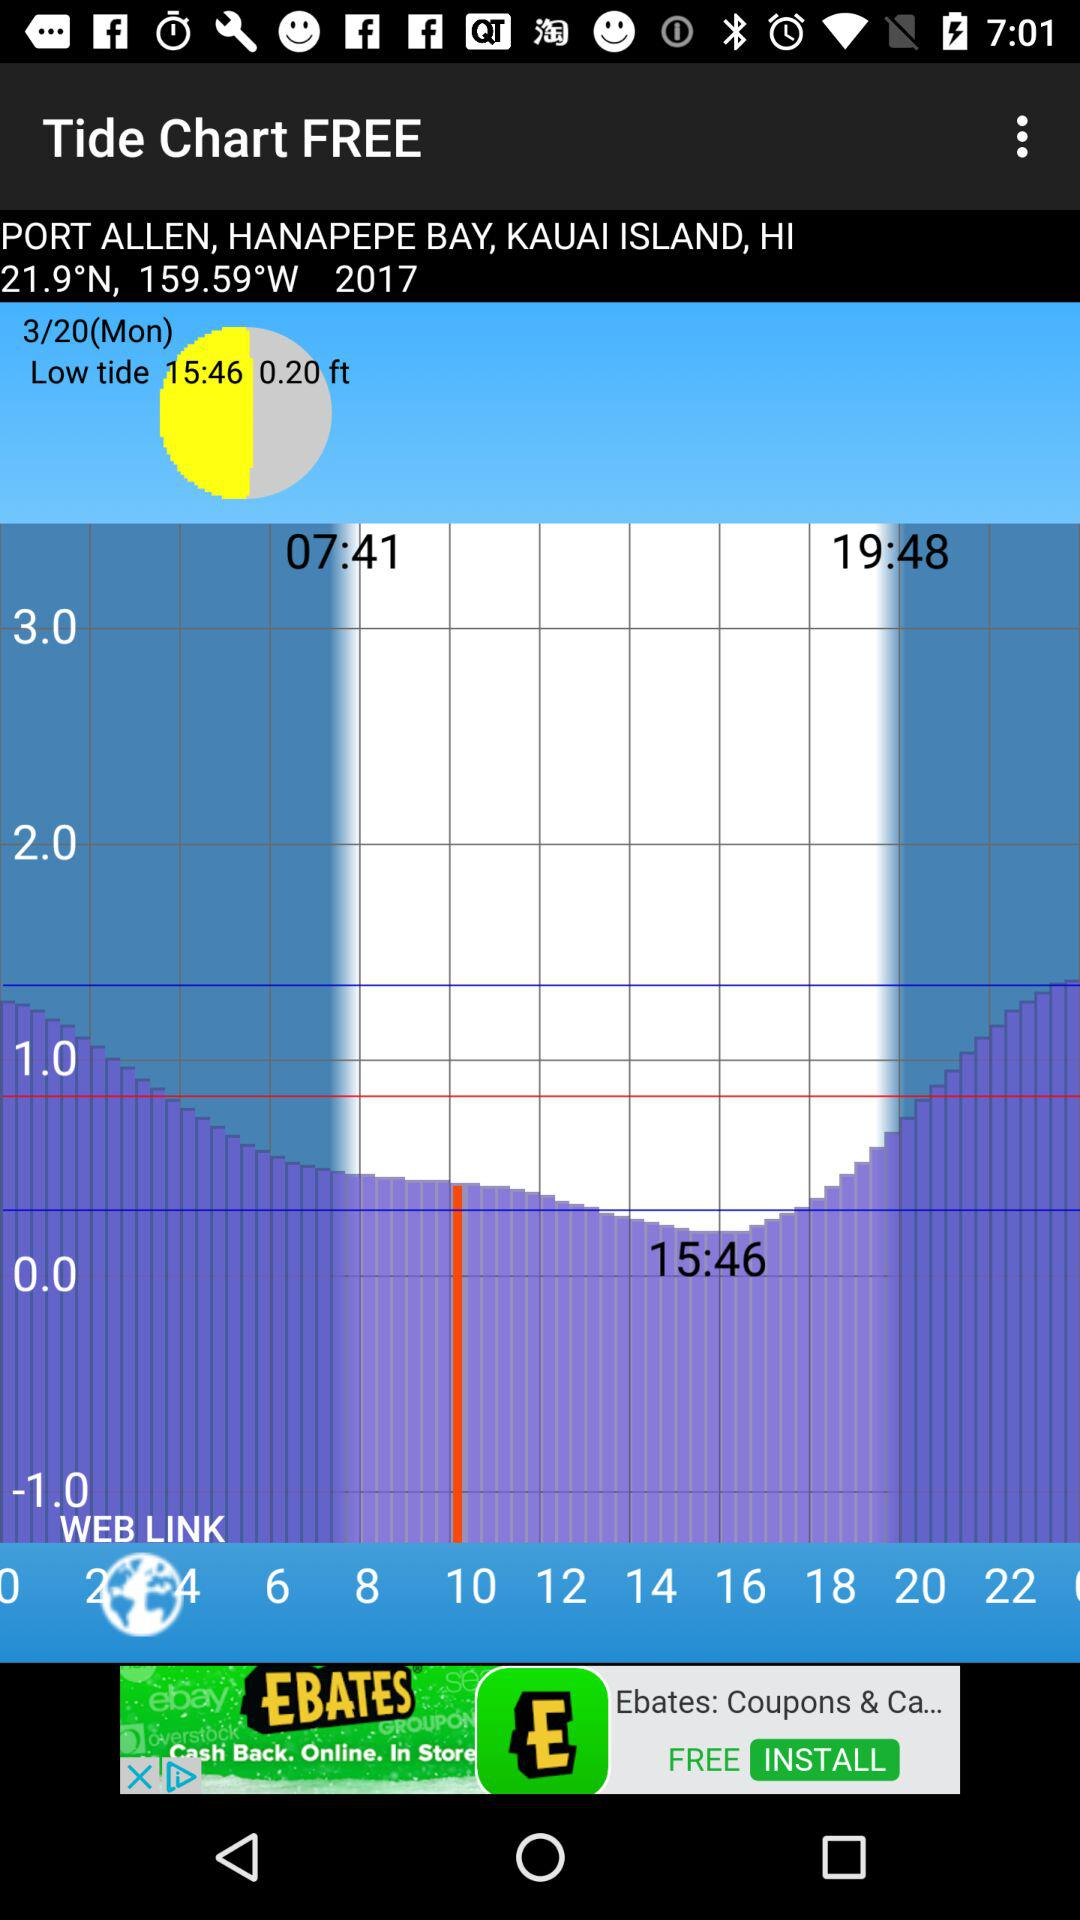When was low tide on Tuesday?
When the provided information is insufficient, respond with <no answer>. <no answer> 